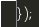Convert code to text. <code><loc_0><loc_0><loc_500><loc_500><_JavaScript_>});
</code> 